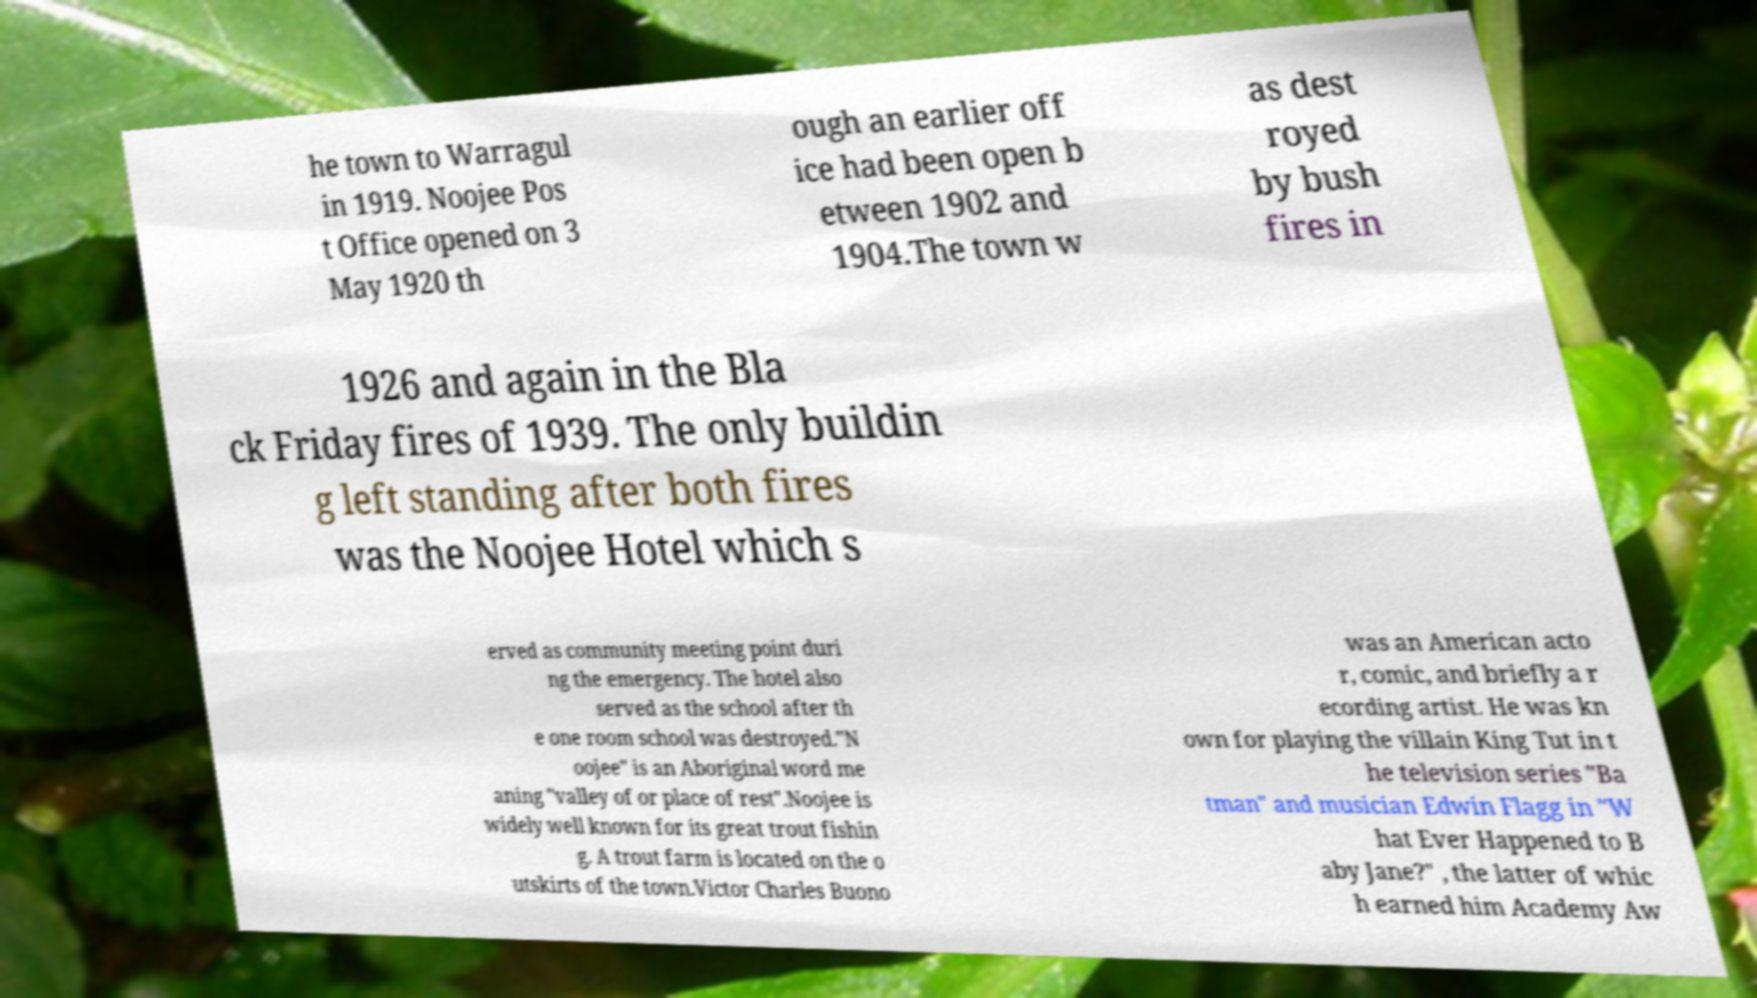Please read and relay the text visible in this image. What does it say? he town to Warragul in 1919. Noojee Pos t Office opened on 3 May 1920 th ough an earlier off ice had been open b etween 1902 and 1904.The town w as dest royed by bush fires in 1926 and again in the Bla ck Friday fires of 1939. The only buildin g left standing after both fires was the Noojee Hotel which s erved as community meeting point duri ng the emergency. The hotel also served as the school after th e one room school was destroyed."N oojee" is an Aboriginal word me aning "valley of or place of rest".Noojee is widely well known for its great trout fishin g. A trout farm is located on the o utskirts of the town.Victor Charles Buono was an American acto r, comic, and briefly a r ecording artist. He was kn own for playing the villain King Tut in t he television series "Ba tman" and musician Edwin Flagg in "W hat Ever Happened to B aby Jane?" , the latter of whic h earned him Academy Aw 